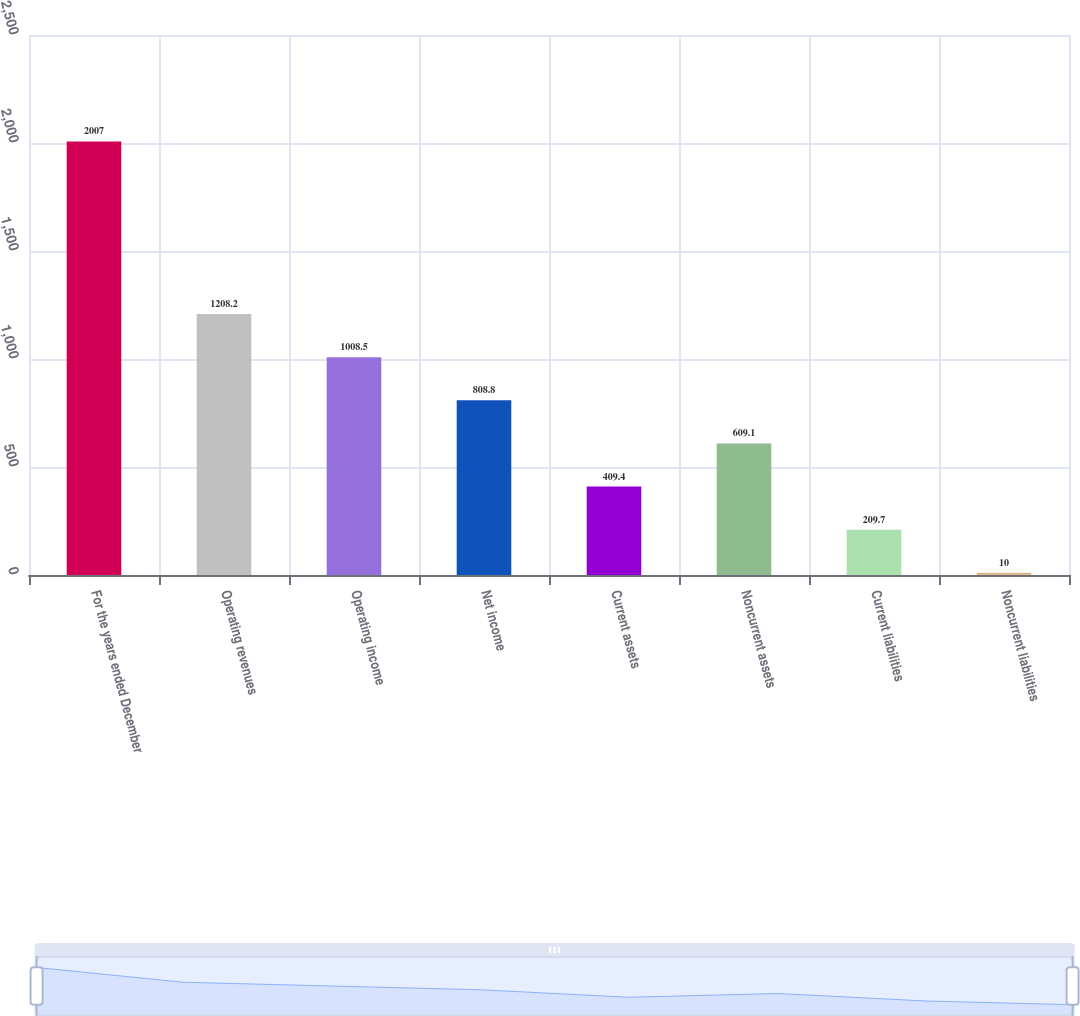Convert chart. <chart><loc_0><loc_0><loc_500><loc_500><bar_chart><fcel>For the years ended December<fcel>Operating revenues<fcel>Operating income<fcel>Net income<fcel>Current assets<fcel>Noncurrent assets<fcel>Current liabilities<fcel>Noncurrent liabilities<nl><fcel>2007<fcel>1208.2<fcel>1008.5<fcel>808.8<fcel>409.4<fcel>609.1<fcel>209.7<fcel>10<nl></chart> 